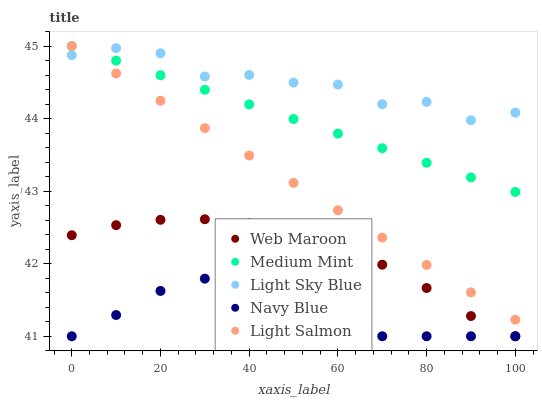Does Navy Blue have the minimum area under the curve?
Answer yes or no. Yes. Does Light Sky Blue have the maximum area under the curve?
Answer yes or no. Yes. Does Light Salmon have the minimum area under the curve?
Answer yes or no. No. Does Light Salmon have the maximum area under the curve?
Answer yes or no. No. Is Light Salmon the smoothest?
Answer yes or no. Yes. Is Light Sky Blue the roughest?
Answer yes or no. Yes. Is Navy Blue the smoothest?
Answer yes or no. No. Is Navy Blue the roughest?
Answer yes or no. No. Does Navy Blue have the lowest value?
Answer yes or no. Yes. Does Light Salmon have the lowest value?
Answer yes or no. No. Does Light Salmon have the highest value?
Answer yes or no. Yes. Does Navy Blue have the highest value?
Answer yes or no. No. Is Web Maroon less than Medium Mint?
Answer yes or no. Yes. Is Light Sky Blue greater than Web Maroon?
Answer yes or no. Yes. Does Light Salmon intersect Medium Mint?
Answer yes or no. Yes. Is Light Salmon less than Medium Mint?
Answer yes or no. No. Is Light Salmon greater than Medium Mint?
Answer yes or no. No. Does Web Maroon intersect Medium Mint?
Answer yes or no. No. 